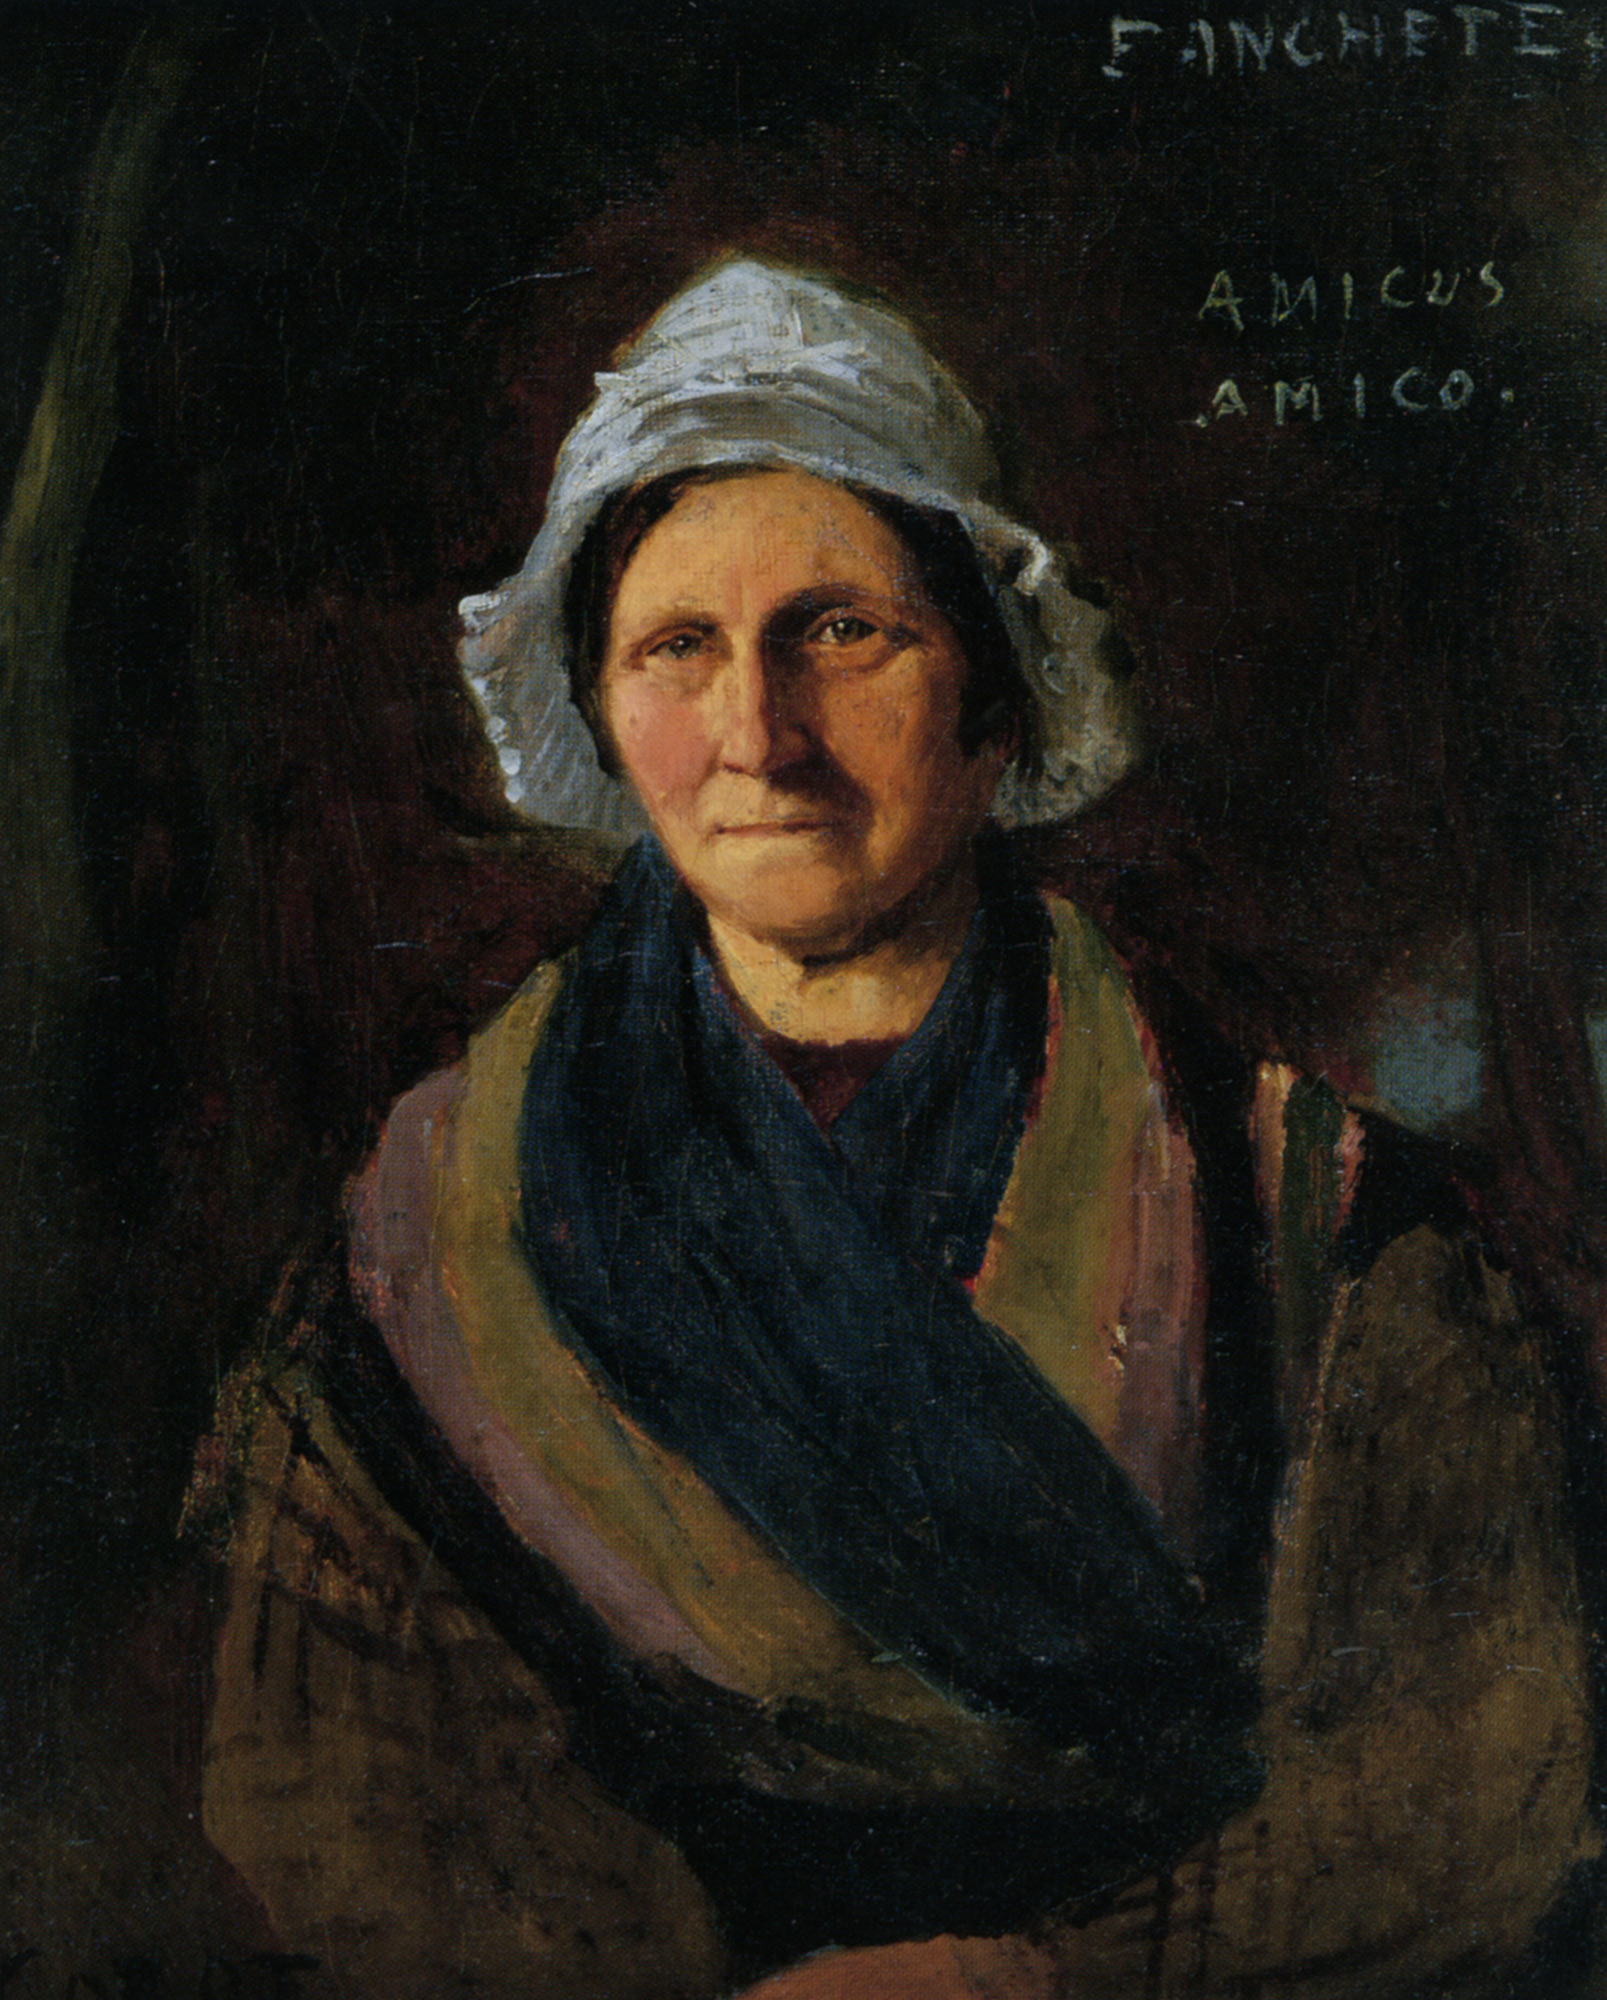Imagine if the woman in the painting could speak. What would she say about her life? If the woman in the painting could speak, she might recount tales of a life filled with both joy and sorrow. She could speak of her family, the children she raised, and the community she supported. Perhaps she would narrate the challenges she faced, the wars or economic upheavals she endured, and how she persevered through them all. Her calm yet stern expression might hide stories of personal loss and victories, of love given and received, and of the wisdom gained through years of experience.  What could the setting of this painting be? Describe it in detail. The setting of this painting, though not explicitly detailed, can be imagined as a humble abode or a rural landscape. The dark background might represent the interior of a modest home, lit by a single, unseen light source. Flickering shadows could play against rough wooden walls or well-worn furniture. Alternatively, if the background is a twilight sky, it might suggest a serene countryside, with the woman perhaps returning from a long day of labor. The simplicity and quiet dignity of the setting reflect the woman’s character, adding depth to her story.  Imagine a fantastical scenario where the painting comes to life. How would the scene unfold? In a fantastical scenario, the painting could come to life in a magical and dreamlike manner. The woman, slowly animating, steps out from the canvas into a dimly lit room. She adjusts her bonnet and shawl, her expressions softening as she takes in her new surroundings, a mix of wonder and realization gleaming in her eyes. The dark background of the painting dissolves into a lush, enchanted forest scene that now surrounds her. Golden light filters through the dense foliage, illuminating ancient trees and mystical creatures hidden among the shadows. As she explores this magical realm, she might meet ethereal beings who share wisdom and tales from forgotten times. The inscription ‘AMICUS AMICO’ glows faintly on a distant tree, guiding her path and reminding her of the timeless friendship and bonds that transcend even the boundaries of art. 